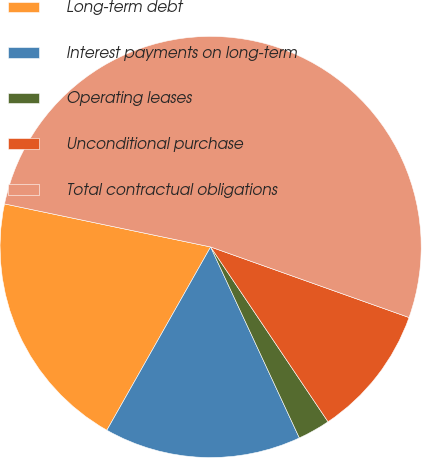Convert chart. <chart><loc_0><loc_0><loc_500><loc_500><pie_chart><fcel>Long-term debt<fcel>Interest payments on long-term<fcel>Operating leases<fcel>Unconditional purchase<fcel>Total contractual obligations<nl><fcel>20.08%<fcel>15.12%<fcel>2.49%<fcel>10.15%<fcel>52.16%<nl></chart> 